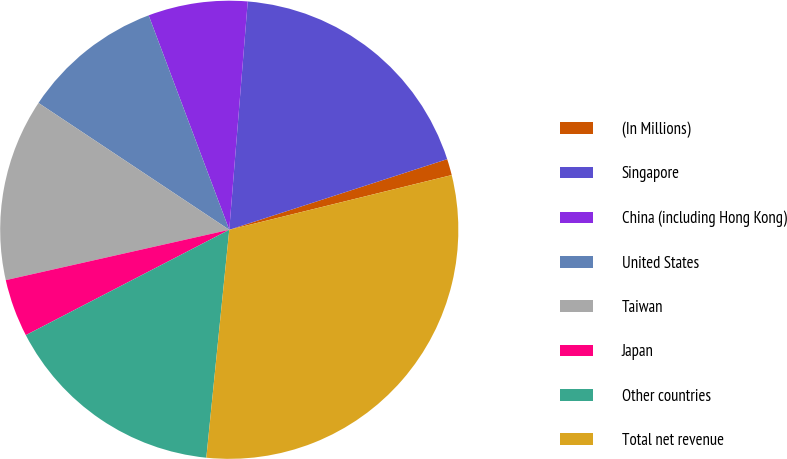<chart> <loc_0><loc_0><loc_500><loc_500><pie_chart><fcel>(In Millions)<fcel>Singapore<fcel>China (including Hong Kong)<fcel>United States<fcel>Taiwan<fcel>Japan<fcel>Other countries<fcel>Total net revenue<nl><fcel>1.15%<fcel>18.73%<fcel>7.01%<fcel>9.94%<fcel>12.87%<fcel>4.08%<fcel>15.8%<fcel>30.44%<nl></chart> 